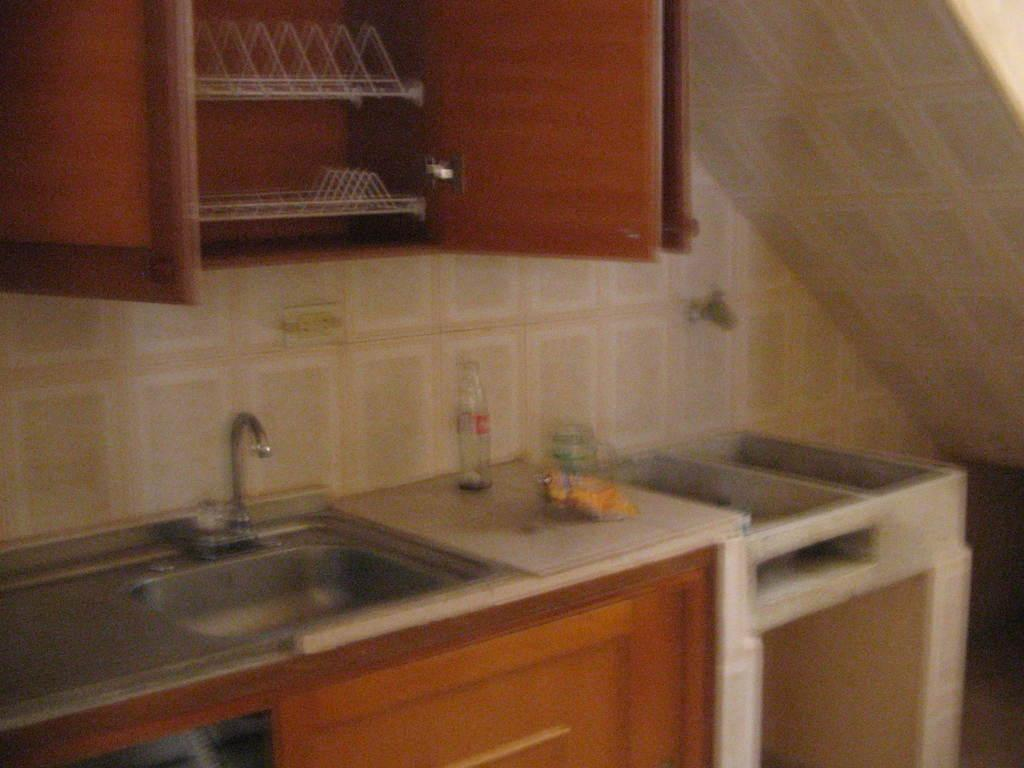Where was the image taken? The image is taken indoors. What is the main feature in the center of the image? There is a kitchen platform in the center of the image. What items can be seen on the kitchen platform? There are bottles and a washbasin on the kitchen platform. What is attached to the washbasin? There is a tap on the kitchen platform. What is visible on the wall in the image? There is a wooden cabinet on the wall. What is the rate of the lift in the image? There is no lift present in the image. How many cabbages are on the kitchen platform? There are no cabbages visible on the kitchen platform in the image. 